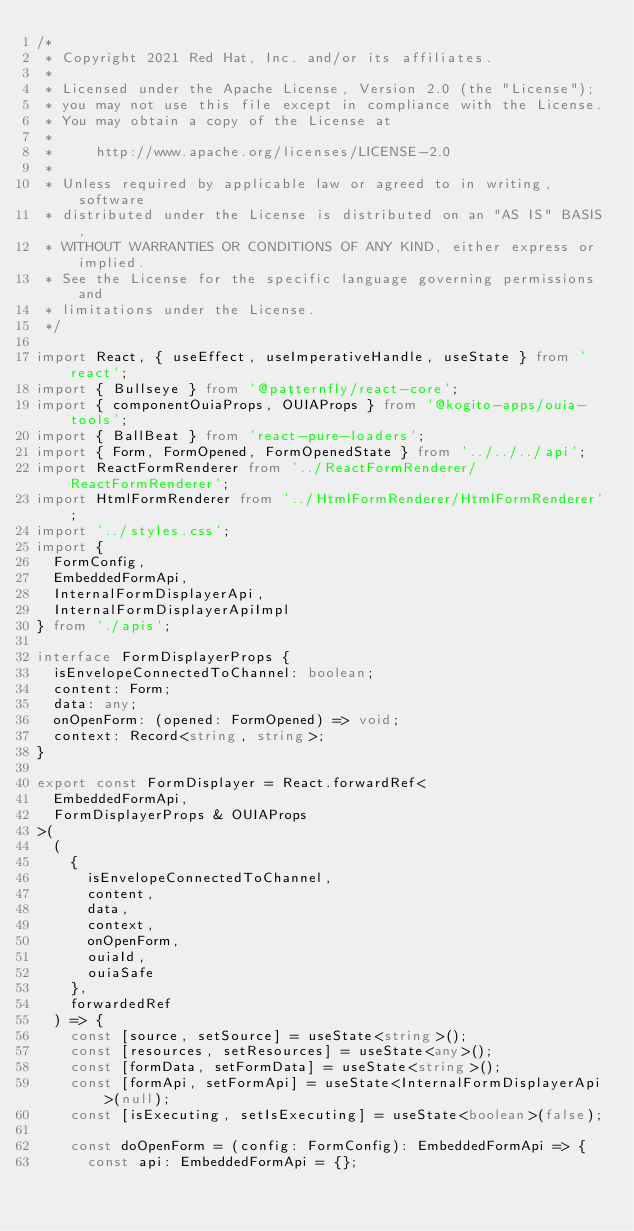<code> <loc_0><loc_0><loc_500><loc_500><_TypeScript_>/*
 * Copyright 2021 Red Hat, Inc. and/or its affiliates.
 *
 * Licensed under the Apache License, Version 2.0 (the "License");
 * you may not use this file except in compliance with the License.
 * You may obtain a copy of the License at
 *
 *     http://www.apache.org/licenses/LICENSE-2.0
 *
 * Unless required by applicable law or agreed to in writing, software
 * distributed under the License is distributed on an "AS IS" BASIS,
 * WITHOUT WARRANTIES OR CONDITIONS OF ANY KIND, either express or implied.
 * See the License for the specific language governing permissions and
 * limitations under the License.
 */

import React, { useEffect, useImperativeHandle, useState } from 'react';
import { Bullseye } from '@patternfly/react-core';
import { componentOuiaProps, OUIAProps } from '@kogito-apps/ouia-tools';
import { BallBeat } from 'react-pure-loaders';
import { Form, FormOpened, FormOpenedState } from '../../../api';
import ReactFormRenderer from '../ReactFormRenderer/ReactFormRenderer';
import HtmlFormRenderer from '../HtmlFormRenderer/HtmlFormRenderer';
import '../styles.css';
import {
  FormConfig,
  EmbeddedFormApi,
  InternalFormDisplayerApi,
  InternalFormDisplayerApiImpl
} from './apis';

interface FormDisplayerProps {
  isEnvelopeConnectedToChannel: boolean;
  content: Form;
  data: any;
  onOpenForm: (opened: FormOpened) => void;
  context: Record<string, string>;
}

export const FormDisplayer = React.forwardRef<
  EmbeddedFormApi,
  FormDisplayerProps & OUIAProps
>(
  (
    {
      isEnvelopeConnectedToChannel,
      content,
      data,
      context,
      onOpenForm,
      ouiaId,
      ouiaSafe
    },
    forwardedRef
  ) => {
    const [source, setSource] = useState<string>();
    const [resources, setResources] = useState<any>();
    const [formData, setFormData] = useState<string>();
    const [formApi, setFormApi] = useState<InternalFormDisplayerApi>(null);
    const [isExecuting, setIsExecuting] = useState<boolean>(false);

    const doOpenForm = (config: FormConfig): EmbeddedFormApi => {
      const api: EmbeddedFormApi = {};</code> 